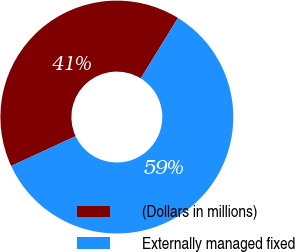Convert chart. <chart><loc_0><loc_0><loc_500><loc_500><pie_chart><fcel>(Dollars in millions)<fcel>Externally managed fixed<nl><fcel>40.7%<fcel>59.3%<nl></chart> 